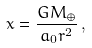<formula> <loc_0><loc_0><loc_500><loc_500>x = \frac { G M _ { \oplus } } { a _ { 0 } r ^ { 2 } } \, ,</formula> 